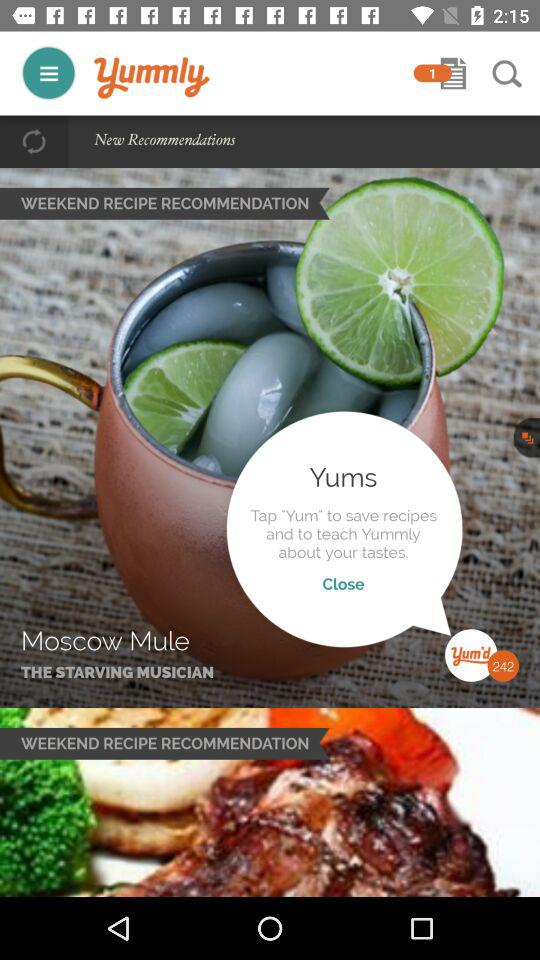What is the number in yum'd? The number in yum'd is 242. 